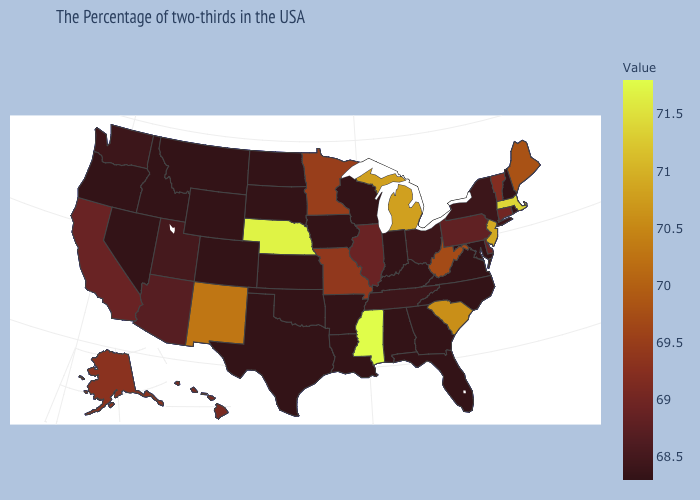Is the legend a continuous bar?
Short answer required. Yes. Does the map have missing data?
Short answer required. No. Which states have the highest value in the USA?
Give a very brief answer. Mississippi. Does Massachusetts have the lowest value in the Northeast?
Give a very brief answer. No. Is the legend a continuous bar?
Short answer required. Yes. Does Colorado have a higher value than Mississippi?
Concise answer only. No. 